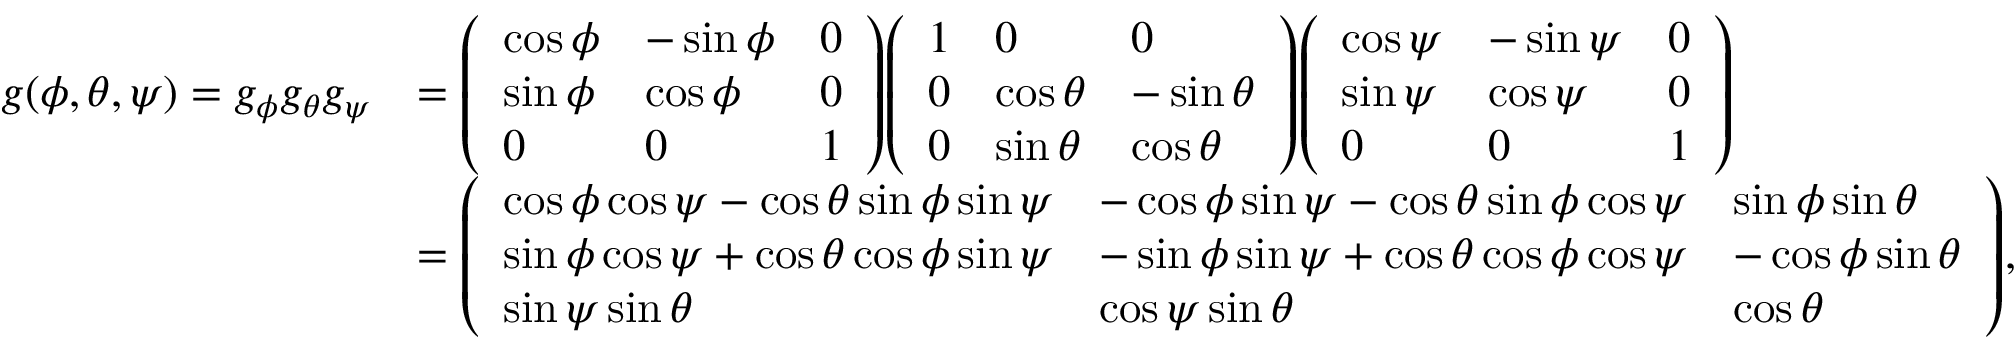<formula> <loc_0><loc_0><loc_500><loc_500>{ \begin{array} { r l } { g ( \phi , \theta , \psi ) = g _ { \phi } g _ { \theta } g _ { \psi } } & { = { \left ( \begin{array} { l l l } { \cos \phi } & { - \sin \phi } & { 0 } \\ { \sin \phi } & { \cos \phi } & { 0 } \\ { 0 } & { 0 } & { 1 } \end{array} \right ) } { \left ( \begin{array} { l l l } { 1 } & { 0 } & { 0 } \\ { 0 } & { \cos \theta } & { - \sin \theta } \\ { 0 } & { \sin \theta } & { \cos \theta } \end{array} \right ) } { \left ( \begin{array} { l l l } { \cos \psi } & { - \sin \psi } & { 0 } \\ { \sin \psi } & { \cos \psi } & { 0 } \\ { 0 } & { 0 } & { 1 } \end{array} \right ) } } \\ & { = { \left ( \begin{array} { l l l } { \cos \phi \cos \psi - \cos \theta \sin \phi \sin \psi } & { - \cos \phi \sin \psi - \cos \theta \sin \phi \cos \psi } & { \sin \phi \sin \theta } \\ { \sin \phi \cos \psi + \cos \theta \cos \phi \sin \psi } & { - \sin \phi \sin \psi + \cos \theta \cos \phi \cos \psi } & { - \cos \phi \sin \theta } \\ { \sin \psi \sin \theta } & { \cos \psi \sin \theta } & { \cos \theta } \end{array} \right ) } , } \end{array} }</formula> 